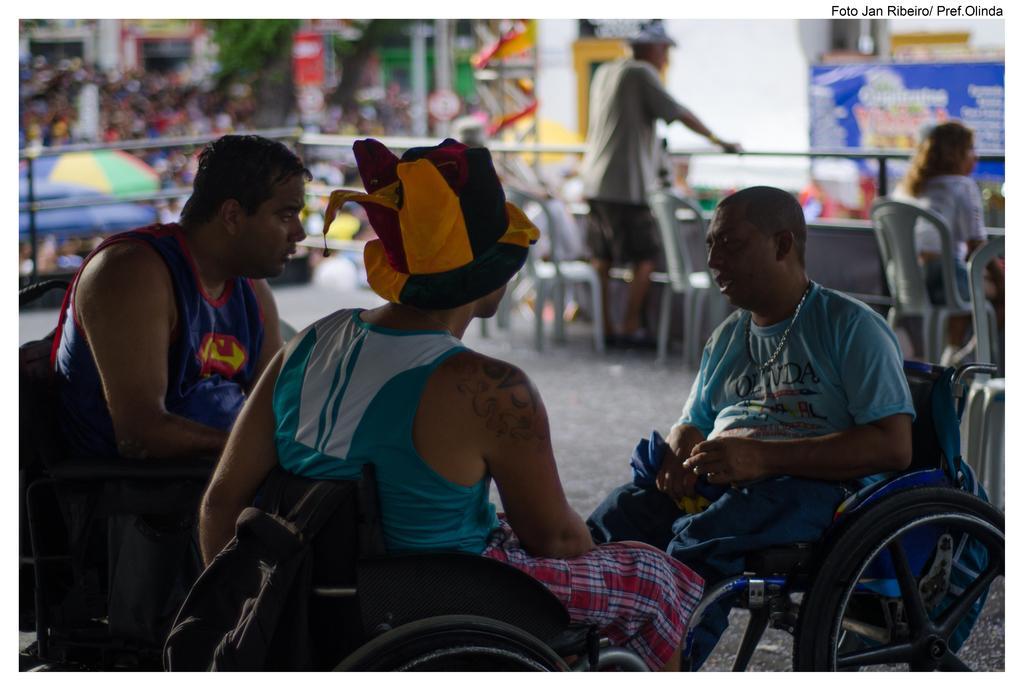How would you summarize this image in a sentence or two? In this picture I can see three people sitting on a wheelchair. I can see a person wearing hat. I can see a person sitting on a chair on the right side. I can see a person standing. I can see a metal grill fence. 